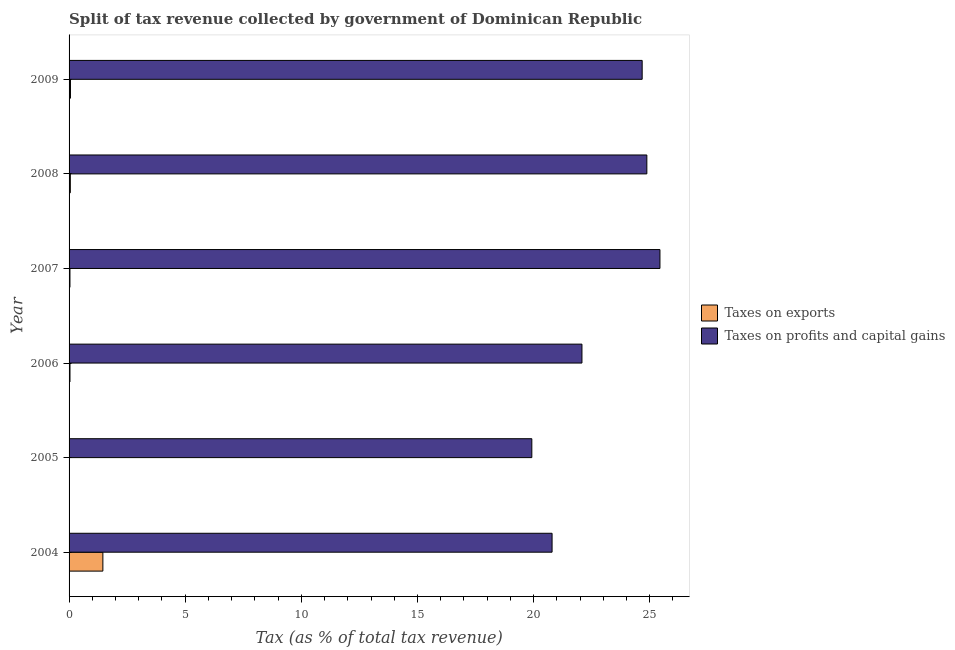How many groups of bars are there?
Your answer should be very brief. 6. Are the number of bars per tick equal to the number of legend labels?
Offer a very short reply. Yes. In how many cases, is the number of bars for a given year not equal to the number of legend labels?
Make the answer very short. 0. What is the percentage of revenue obtained from taxes on profits and capital gains in 2004?
Keep it short and to the point. 20.8. Across all years, what is the maximum percentage of revenue obtained from taxes on profits and capital gains?
Ensure brevity in your answer.  25.44. Across all years, what is the minimum percentage of revenue obtained from taxes on exports?
Give a very brief answer. 0.01. In which year was the percentage of revenue obtained from taxes on exports maximum?
Your answer should be very brief. 2004. What is the total percentage of revenue obtained from taxes on exports in the graph?
Keep it short and to the point. 1.66. What is the difference between the percentage of revenue obtained from taxes on profits and capital gains in 2006 and that in 2007?
Give a very brief answer. -3.36. What is the difference between the percentage of revenue obtained from taxes on profits and capital gains in 2009 and the percentage of revenue obtained from taxes on exports in 2005?
Offer a very short reply. 24.67. What is the average percentage of revenue obtained from taxes on profits and capital gains per year?
Provide a succinct answer. 22.97. In the year 2005, what is the difference between the percentage of revenue obtained from taxes on profits and capital gains and percentage of revenue obtained from taxes on exports?
Ensure brevity in your answer.  19.91. In how many years, is the percentage of revenue obtained from taxes on exports greater than 19 %?
Offer a terse response. 0. What is the ratio of the percentage of revenue obtained from taxes on profits and capital gains in 2005 to that in 2007?
Your response must be concise. 0.78. Is the percentage of revenue obtained from taxes on profits and capital gains in 2005 less than that in 2008?
Give a very brief answer. Yes. Is the difference between the percentage of revenue obtained from taxes on exports in 2005 and 2006 greater than the difference between the percentage of revenue obtained from taxes on profits and capital gains in 2005 and 2006?
Your answer should be very brief. Yes. What is the difference between the highest and the second highest percentage of revenue obtained from taxes on exports?
Your response must be concise. 1.4. What is the difference between the highest and the lowest percentage of revenue obtained from taxes on profits and capital gains?
Provide a short and direct response. 5.52. In how many years, is the percentage of revenue obtained from taxes on profits and capital gains greater than the average percentage of revenue obtained from taxes on profits and capital gains taken over all years?
Offer a very short reply. 3. Is the sum of the percentage of revenue obtained from taxes on exports in 2004 and 2008 greater than the maximum percentage of revenue obtained from taxes on profits and capital gains across all years?
Your answer should be compact. No. What does the 2nd bar from the top in 2008 represents?
Offer a terse response. Taxes on exports. What does the 2nd bar from the bottom in 2004 represents?
Provide a short and direct response. Taxes on profits and capital gains. How many bars are there?
Keep it short and to the point. 12. Are all the bars in the graph horizontal?
Keep it short and to the point. Yes. What is the difference between two consecutive major ticks on the X-axis?
Make the answer very short. 5. Are the values on the major ticks of X-axis written in scientific E-notation?
Your answer should be compact. No. Does the graph contain any zero values?
Keep it short and to the point. No. Where does the legend appear in the graph?
Give a very brief answer. Center right. How many legend labels are there?
Offer a terse response. 2. How are the legend labels stacked?
Make the answer very short. Vertical. What is the title of the graph?
Give a very brief answer. Split of tax revenue collected by government of Dominican Republic. Does "Travel services" appear as one of the legend labels in the graph?
Your answer should be compact. No. What is the label or title of the X-axis?
Your answer should be very brief. Tax (as % of total tax revenue). What is the Tax (as % of total tax revenue) in Taxes on exports in 2004?
Provide a short and direct response. 1.46. What is the Tax (as % of total tax revenue) of Taxes on profits and capital gains in 2004?
Give a very brief answer. 20.8. What is the Tax (as % of total tax revenue) in Taxes on exports in 2005?
Provide a short and direct response. 0.01. What is the Tax (as % of total tax revenue) of Taxes on profits and capital gains in 2005?
Provide a short and direct response. 19.92. What is the Tax (as % of total tax revenue) of Taxes on exports in 2006?
Give a very brief answer. 0.04. What is the Tax (as % of total tax revenue) in Taxes on profits and capital gains in 2006?
Offer a very short reply. 22.08. What is the Tax (as % of total tax revenue) in Taxes on exports in 2007?
Provide a succinct answer. 0.04. What is the Tax (as % of total tax revenue) of Taxes on profits and capital gains in 2007?
Give a very brief answer. 25.44. What is the Tax (as % of total tax revenue) of Taxes on exports in 2008?
Your response must be concise. 0.05. What is the Tax (as % of total tax revenue) in Taxes on profits and capital gains in 2008?
Provide a short and direct response. 24.88. What is the Tax (as % of total tax revenue) in Taxes on exports in 2009?
Give a very brief answer. 0.06. What is the Tax (as % of total tax revenue) in Taxes on profits and capital gains in 2009?
Provide a succinct answer. 24.67. Across all years, what is the maximum Tax (as % of total tax revenue) in Taxes on exports?
Offer a terse response. 1.46. Across all years, what is the maximum Tax (as % of total tax revenue) in Taxes on profits and capital gains?
Your answer should be compact. 25.44. Across all years, what is the minimum Tax (as % of total tax revenue) of Taxes on exports?
Offer a terse response. 0.01. Across all years, what is the minimum Tax (as % of total tax revenue) in Taxes on profits and capital gains?
Ensure brevity in your answer.  19.92. What is the total Tax (as % of total tax revenue) of Taxes on exports in the graph?
Keep it short and to the point. 1.66. What is the total Tax (as % of total tax revenue) in Taxes on profits and capital gains in the graph?
Offer a very short reply. 137.79. What is the difference between the Tax (as % of total tax revenue) of Taxes on exports in 2004 and that in 2005?
Provide a short and direct response. 1.45. What is the difference between the Tax (as % of total tax revenue) of Taxes on profits and capital gains in 2004 and that in 2005?
Your answer should be very brief. 0.87. What is the difference between the Tax (as % of total tax revenue) of Taxes on exports in 2004 and that in 2006?
Your response must be concise. 1.42. What is the difference between the Tax (as % of total tax revenue) of Taxes on profits and capital gains in 2004 and that in 2006?
Your response must be concise. -1.29. What is the difference between the Tax (as % of total tax revenue) in Taxes on exports in 2004 and that in 2007?
Offer a terse response. 1.42. What is the difference between the Tax (as % of total tax revenue) of Taxes on profits and capital gains in 2004 and that in 2007?
Ensure brevity in your answer.  -4.64. What is the difference between the Tax (as % of total tax revenue) of Taxes on exports in 2004 and that in 2008?
Provide a succinct answer. 1.4. What is the difference between the Tax (as % of total tax revenue) of Taxes on profits and capital gains in 2004 and that in 2008?
Ensure brevity in your answer.  -4.08. What is the difference between the Tax (as % of total tax revenue) in Taxes on exports in 2004 and that in 2009?
Make the answer very short. 1.4. What is the difference between the Tax (as % of total tax revenue) in Taxes on profits and capital gains in 2004 and that in 2009?
Your response must be concise. -3.88. What is the difference between the Tax (as % of total tax revenue) of Taxes on exports in 2005 and that in 2006?
Offer a very short reply. -0.03. What is the difference between the Tax (as % of total tax revenue) in Taxes on profits and capital gains in 2005 and that in 2006?
Ensure brevity in your answer.  -2.16. What is the difference between the Tax (as % of total tax revenue) of Taxes on exports in 2005 and that in 2007?
Keep it short and to the point. -0.03. What is the difference between the Tax (as % of total tax revenue) of Taxes on profits and capital gains in 2005 and that in 2007?
Give a very brief answer. -5.52. What is the difference between the Tax (as % of total tax revenue) in Taxes on exports in 2005 and that in 2008?
Provide a short and direct response. -0.05. What is the difference between the Tax (as % of total tax revenue) in Taxes on profits and capital gains in 2005 and that in 2008?
Make the answer very short. -4.95. What is the difference between the Tax (as % of total tax revenue) of Taxes on exports in 2005 and that in 2009?
Your answer should be compact. -0.05. What is the difference between the Tax (as % of total tax revenue) in Taxes on profits and capital gains in 2005 and that in 2009?
Ensure brevity in your answer.  -4.75. What is the difference between the Tax (as % of total tax revenue) in Taxes on exports in 2006 and that in 2007?
Make the answer very short. 0. What is the difference between the Tax (as % of total tax revenue) of Taxes on profits and capital gains in 2006 and that in 2007?
Offer a terse response. -3.36. What is the difference between the Tax (as % of total tax revenue) in Taxes on exports in 2006 and that in 2008?
Give a very brief answer. -0.02. What is the difference between the Tax (as % of total tax revenue) in Taxes on profits and capital gains in 2006 and that in 2008?
Your answer should be very brief. -2.79. What is the difference between the Tax (as % of total tax revenue) in Taxes on exports in 2006 and that in 2009?
Make the answer very short. -0.02. What is the difference between the Tax (as % of total tax revenue) in Taxes on profits and capital gains in 2006 and that in 2009?
Offer a very short reply. -2.59. What is the difference between the Tax (as % of total tax revenue) in Taxes on exports in 2007 and that in 2008?
Make the answer very short. -0.02. What is the difference between the Tax (as % of total tax revenue) in Taxes on profits and capital gains in 2007 and that in 2008?
Your answer should be very brief. 0.56. What is the difference between the Tax (as % of total tax revenue) in Taxes on exports in 2007 and that in 2009?
Ensure brevity in your answer.  -0.02. What is the difference between the Tax (as % of total tax revenue) of Taxes on profits and capital gains in 2007 and that in 2009?
Provide a short and direct response. 0.77. What is the difference between the Tax (as % of total tax revenue) in Taxes on exports in 2008 and that in 2009?
Your answer should be compact. -0.01. What is the difference between the Tax (as % of total tax revenue) of Taxes on profits and capital gains in 2008 and that in 2009?
Your answer should be compact. 0.2. What is the difference between the Tax (as % of total tax revenue) in Taxes on exports in 2004 and the Tax (as % of total tax revenue) in Taxes on profits and capital gains in 2005?
Provide a succinct answer. -18.47. What is the difference between the Tax (as % of total tax revenue) of Taxes on exports in 2004 and the Tax (as % of total tax revenue) of Taxes on profits and capital gains in 2006?
Offer a terse response. -20.63. What is the difference between the Tax (as % of total tax revenue) of Taxes on exports in 2004 and the Tax (as % of total tax revenue) of Taxes on profits and capital gains in 2007?
Your response must be concise. -23.98. What is the difference between the Tax (as % of total tax revenue) of Taxes on exports in 2004 and the Tax (as % of total tax revenue) of Taxes on profits and capital gains in 2008?
Make the answer very short. -23.42. What is the difference between the Tax (as % of total tax revenue) in Taxes on exports in 2004 and the Tax (as % of total tax revenue) in Taxes on profits and capital gains in 2009?
Provide a short and direct response. -23.22. What is the difference between the Tax (as % of total tax revenue) of Taxes on exports in 2005 and the Tax (as % of total tax revenue) of Taxes on profits and capital gains in 2006?
Your response must be concise. -22.07. What is the difference between the Tax (as % of total tax revenue) of Taxes on exports in 2005 and the Tax (as % of total tax revenue) of Taxes on profits and capital gains in 2007?
Keep it short and to the point. -25.43. What is the difference between the Tax (as % of total tax revenue) of Taxes on exports in 2005 and the Tax (as % of total tax revenue) of Taxes on profits and capital gains in 2008?
Your answer should be very brief. -24.87. What is the difference between the Tax (as % of total tax revenue) of Taxes on exports in 2005 and the Tax (as % of total tax revenue) of Taxes on profits and capital gains in 2009?
Ensure brevity in your answer.  -24.67. What is the difference between the Tax (as % of total tax revenue) of Taxes on exports in 2006 and the Tax (as % of total tax revenue) of Taxes on profits and capital gains in 2007?
Provide a succinct answer. -25.4. What is the difference between the Tax (as % of total tax revenue) in Taxes on exports in 2006 and the Tax (as % of total tax revenue) in Taxes on profits and capital gains in 2008?
Your answer should be very brief. -24.84. What is the difference between the Tax (as % of total tax revenue) in Taxes on exports in 2006 and the Tax (as % of total tax revenue) in Taxes on profits and capital gains in 2009?
Offer a very short reply. -24.64. What is the difference between the Tax (as % of total tax revenue) of Taxes on exports in 2007 and the Tax (as % of total tax revenue) of Taxes on profits and capital gains in 2008?
Make the answer very short. -24.84. What is the difference between the Tax (as % of total tax revenue) in Taxes on exports in 2007 and the Tax (as % of total tax revenue) in Taxes on profits and capital gains in 2009?
Your response must be concise. -24.64. What is the difference between the Tax (as % of total tax revenue) of Taxes on exports in 2008 and the Tax (as % of total tax revenue) of Taxes on profits and capital gains in 2009?
Offer a terse response. -24.62. What is the average Tax (as % of total tax revenue) in Taxes on exports per year?
Ensure brevity in your answer.  0.28. What is the average Tax (as % of total tax revenue) of Taxes on profits and capital gains per year?
Your answer should be very brief. 22.97. In the year 2004, what is the difference between the Tax (as % of total tax revenue) of Taxes on exports and Tax (as % of total tax revenue) of Taxes on profits and capital gains?
Keep it short and to the point. -19.34. In the year 2005, what is the difference between the Tax (as % of total tax revenue) in Taxes on exports and Tax (as % of total tax revenue) in Taxes on profits and capital gains?
Offer a terse response. -19.91. In the year 2006, what is the difference between the Tax (as % of total tax revenue) of Taxes on exports and Tax (as % of total tax revenue) of Taxes on profits and capital gains?
Offer a very short reply. -22.04. In the year 2007, what is the difference between the Tax (as % of total tax revenue) of Taxes on exports and Tax (as % of total tax revenue) of Taxes on profits and capital gains?
Your answer should be compact. -25.4. In the year 2008, what is the difference between the Tax (as % of total tax revenue) of Taxes on exports and Tax (as % of total tax revenue) of Taxes on profits and capital gains?
Your response must be concise. -24.82. In the year 2009, what is the difference between the Tax (as % of total tax revenue) of Taxes on exports and Tax (as % of total tax revenue) of Taxes on profits and capital gains?
Provide a succinct answer. -24.61. What is the ratio of the Tax (as % of total tax revenue) in Taxes on exports in 2004 to that in 2005?
Make the answer very short. 159.23. What is the ratio of the Tax (as % of total tax revenue) in Taxes on profits and capital gains in 2004 to that in 2005?
Keep it short and to the point. 1.04. What is the ratio of the Tax (as % of total tax revenue) of Taxes on exports in 2004 to that in 2006?
Ensure brevity in your answer.  37.25. What is the ratio of the Tax (as % of total tax revenue) in Taxes on profits and capital gains in 2004 to that in 2006?
Your answer should be very brief. 0.94. What is the ratio of the Tax (as % of total tax revenue) in Taxes on exports in 2004 to that in 2007?
Your answer should be compact. 38.3. What is the ratio of the Tax (as % of total tax revenue) of Taxes on profits and capital gains in 2004 to that in 2007?
Give a very brief answer. 0.82. What is the ratio of the Tax (as % of total tax revenue) in Taxes on exports in 2004 to that in 2008?
Your answer should be compact. 26.73. What is the ratio of the Tax (as % of total tax revenue) in Taxes on profits and capital gains in 2004 to that in 2008?
Your response must be concise. 0.84. What is the ratio of the Tax (as % of total tax revenue) in Taxes on exports in 2004 to that in 2009?
Your answer should be compact. 24.25. What is the ratio of the Tax (as % of total tax revenue) of Taxes on profits and capital gains in 2004 to that in 2009?
Make the answer very short. 0.84. What is the ratio of the Tax (as % of total tax revenue) in Taxes on exports in 2005 to that in 2006?
Offer a terse response. 0.23. What is the ratio of the Tax (as % of total tax revenue) of Taxes on profits and capital gains in 2005 to that in 2006?
Keep it short and to the point. 0.9. What is the ratio of the Tax (as % of total tax revenue) in Taxes on exports in 2005 to that in 2007?
Your answer should be very brief. 0.24. What is the ratio of the Tax (as % of total tax revenue) in Taxes on profits and capital gains in 2005 to that in 2007?
Your answer should be compact. 0.78. What is the ratio of the Tax (as % of total tax revenue) of Taxes on exports in 2005 to that in 2008?
Ensure brevity in your answer.  0.17. What is the ratio of the Tax (as % of total tax revenue) in Taxes on profits and capital gains in 2005 to that in 2008?
Keep it short and to the point. 0.8. What is the ratio of the Tax (as % of total tax revenue) of Taxes on exports in 2005 to that in 2009?
Offer a terse response. 0.15. What is the ratio of the Tax (as % of total tax revenue) of Taxes on profits and capital gains in 2005 to that in 2009?
Make the answer very short. 0.81. What is the ratio of the Tax (as % of total tax revenue) of Taxes on exports in 2006 to that in 2007?
Your answer should be compact. 1.03. What is the ratio of the Tax (as % of total tax revenue) in Taxes on profits and capital gains in 2006 to that in 2007?
Your answer should be compact. 0.87. What is the ratio of the Tax (as % of total tax revenue) in Taxes on exports in 2006 to that in 2008?
Give a very brief answer. 0.72. What is the ratio of the Tax (as % of total tax revenue) of Taxes on profits and capital gains in 2006 to that in 2008?
Provide a short and direct response. 0.89. What is the ratio of the Tax (as % of total tax revenue) of Taxes on exports in 2006 to that in 2009?
Offer a terse response. 0.65. What is the ratio of the Tax (as % of total tax revenue) in Taxes on profits and capital gains in 2006 to that in 2009?
Offer a very short reply. 0.89. What is the ratio of the Tax (as % of total tax revenue) of Taxes on exports in 2007 to that in 2008?
Offer a very short reply. 0.7. What is the ratio of the Tax (as % of total tax revenue) in Taxes on profits and capital gains in 2007 to that in 2008?
Make the answer very short. 1.02. What is the ratio of the Tax (as % of total tax revenue) of Taxes on exports in 2007 to that in 2009?
Your response must be concise. 0.63. What is the ratio of the Tax (as % of total tax revenue) of Taxes on profits and capital gains in 2007 to that in 2009?
Provide a succinct answer. 1.03. What is the ratio of the Tax (as % of total tax revenue) in Taxes on exports in 2008 to that in 2009?
Ensure brevity in your answer.  0.91. What is the ratio of the Tax (as % of total tax revenue) of Taxes on profits and capital gains in 2008 to that in 2009?
Your answer should be very brief. 1.01. What is the difference between the highest and the second highest Tax (as % of total tax revenue) of Taxes on exports?
Provide a short and direct response. 1.4. What is the difference between the highest and the second highest Tax (as % of total tax revenue) of Taxes on profits and capital gains?
Make the answer very short. 0.56. What is the difference between the highest and the lowest Tax (as % of total tax revenue) in Taxes on exports?
Ensure brevity in your answer.  1.45. What is the difference between the highest and the lowest Tax (as % of total tax revenue) in Taxes on profits and capital gains?
Keep it short and to the point. 5.52. 